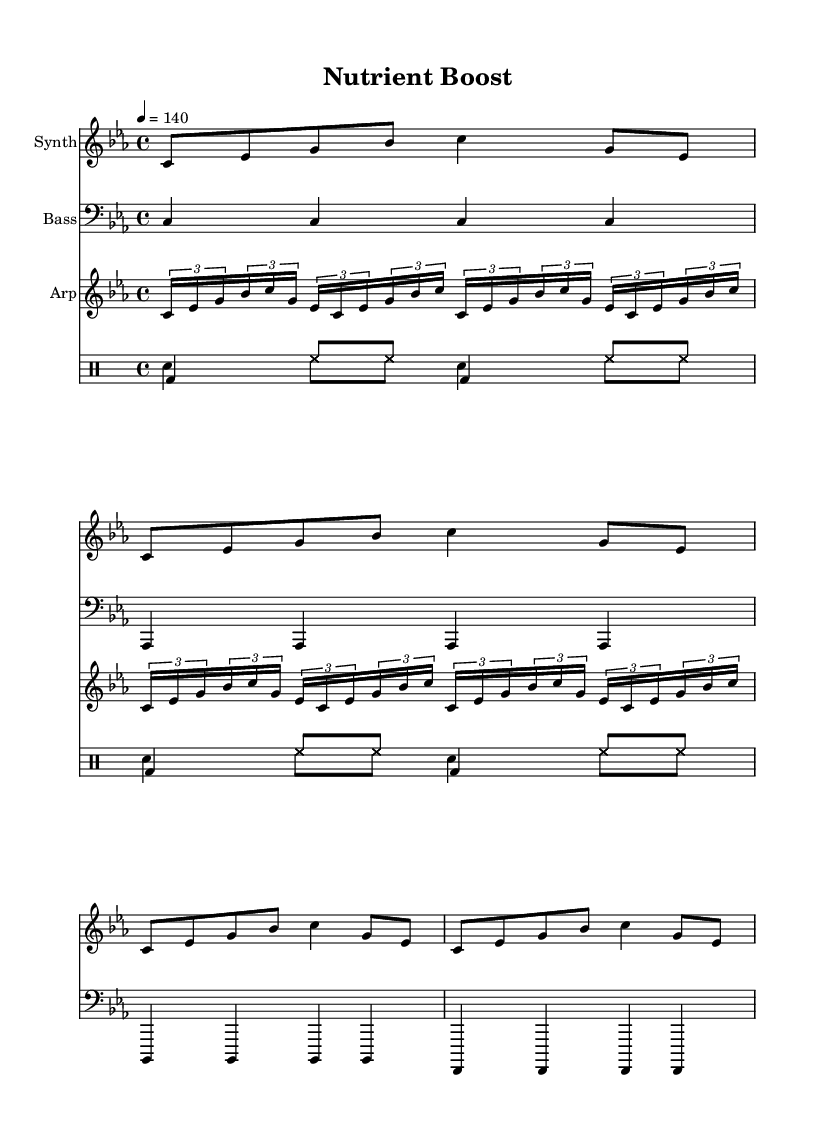What is the key signature of this music? The key signature is C minor, which has three flats (B flat, E flat, and A flat). This can be identified from the initial part of the sheet music where the key is indicated.
Answer: C minor What is the time signature of this piece? The time signature is 4/4, which means there are four quarter note beats in each measure. This is shown at the beginning of the music notation.
Answer: 4/4 What is the tempo marking for this score? The tempo marking is 140 beats per minute, indicated by the notation "4 = 140." This means the quarter note gets the beat and is played at a quick pace.
Answer: 140 How many measures are in the synth part? The synth part has 4 measures, as indicated by the repeated pattern that spans from the first to the fourth measure.
Answer: 4 What rhythmic style is used in the drum pattern? The drum pattern features a steady driving rhythm with alternating bass drum and hi-hat hits, typical of electronic music for high-energy sections. This is observed in the drum patterns provided.
Answer: Steady driving rhythm What type of synthesizer sound is represented in the score? The score represents a 'synth' sound indicated at the beginning of the synth section, which characterizes the electronic music genre with its synthetic and digital nature.
Answer: Synth Which instruments are used in this piece? The piece includes a synthesizer, bass, arpeggiator, and drums. This can be seen from the instrument names listed at the start of each staff in the score.
Answer: Synthesizer, Bass, Arpeggiator, Drums 